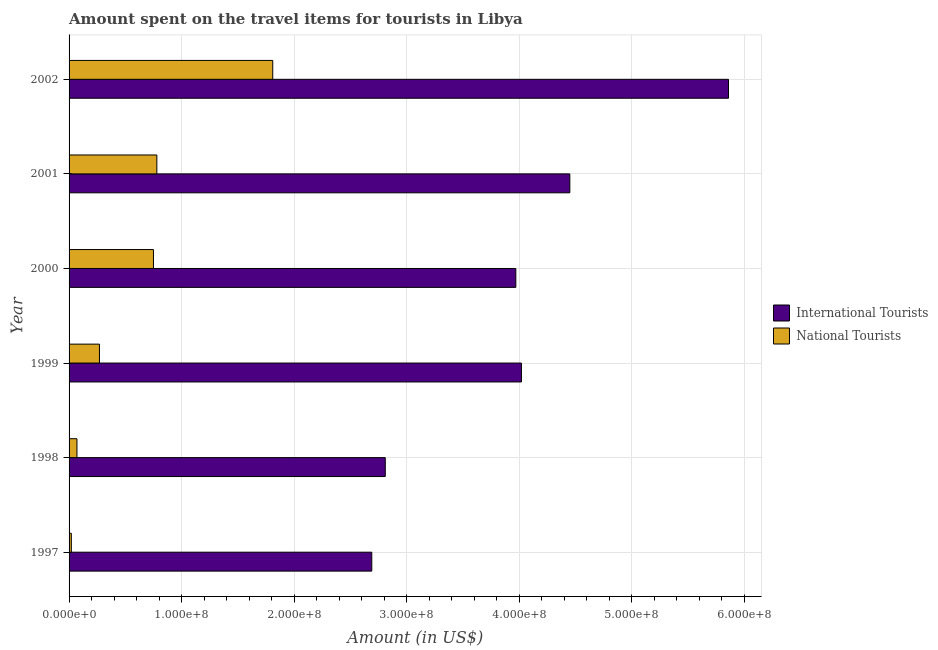How many different coloured bars are there?
Your answer should be compact. 2. How many groups of bars are there?
Make the answer very short. 6. Are the number of bars per tick equal to the number of legend labels?
Keep it short and to the point. Yes. How many bars are there on the 6th tick from the bottom?
Offer a very short reply. 2. What is the amount spent on travel items of international tourists in 1999?
Give a very brief answer. 4.02e+08. Across all years, what is the maximum amount spent on travel items of national tourists?
Your response must be concise. 1.81e+08. Across all years, what is the minimum amount spent on travel items of international tourists?
Provide a short and direct response. 2.69e+08. What is the total amount spent on travel items of national tourists in the graph?
Provide a succinct answer. 3.70e+08. What is the difference between the amount spent on travel items of international tourists in 1998 and that in 2000?
Offer a terse response. -1.16e+08. What is the difference between the amount spent on travel items of international tourists in 1998 and the amount spent on travel items of national tourists in 1997?
Offer a very short reply. 2.79e+08. What is the average amount spent on travel items of national tourists per year?
Provide a short and direct response. 6.17e+07. In the year 2001, what is the difference between the amount spent on travel items of international tourists and amount spent on travel items of national tourists?
Your answer should be very brief. 3.67e+08. What is the ratio of the amount spent on travel items of international tourists in 1998 to that in 2001?
Provide a short and direct response. 0.63. Is the difference between the amount spent on travel items of national tourists in 1999 and 2002 greater than the difference between the amount spent on travel items of international tourists in 1999 and 2002?
Your answer should be compact. Yes. What is the difference between the highest and the second highest amount spent on travel items of international tourists?
Make the answer very short. 1.41e+08. What is the difference between the highest and the lowest amount spent on travel items of national tourists?
Ensure brevity in your answer.  1.79e+08. Is the sum of the amount spent on travel items of international tourists in 1998 and 2001 greater than the maximum amount spent on travel items of national tourists across all years?
Your answer should be very brief. Yes. What does the 2nd bar from the top in 1998 represents?
Offer a very short reply. International Tourists. What does the 1st bar from the bottom in 1998 represents?
Provide a succinct answer. International Tourists. How many bars are there?
Your answer should be compact. 12. Are all the bars in the graph horizontal?
Offer a terse response. Yes. How many years are there in the graph?
Give a very brief answer. 6. What is the difference between two consecutive major ticks on the X-axis?
Offer a very short reply. 1.00e+08. Where does the legend appear in the graph?
Provide a short and direct response. Center right. How are the legend labels stacked?
Offer a terse response. Vertical. What is the title of the graph?
Make the answer very short. Amount spent on the travel items for tourists in Libya. What is the label or title of the Y-axis?
Keep it short and to the point. Year. What is the Amount (in US$) in International Tourists in 1997?
Offer a terse response. 2.69e+08. What is the Amount (in US$) of International Tourists in 1998?
Your response must be concise. 2.81e+08. What is the Amount (in US$) of National Tourists in 1998?
Keep it short and to the point. 7.00e+06. What is the Amount (in US$) of International Tourists in 1999?
Ensure brevity in your answer.  4.02e+08. What is the Amount (in US$) in National Tourists in 1999?
Provide a succinct answer. 2.70e+07. What is the Amount (in US$) in International Tourists in 2000?
Offer a terse response. 3.97e+08. What is the Amount (in US$) in National Tourists in 2000?
Your response must be concise. 7.50e+07. What is the Amount (in US$) of International Tourists in 2001?
Provide a short and direct response. 4.45e+08. What is the Amount (in US$) in National Tourists in 2001?
Your answer should be compact. 7.80e+07. What is the Amount (in US$) of International Tourists in 2002?
Offer a terse response. 5.86e+08. What is the Amount (in US$) of National Tourists in 2002?
Ensure brevity in your answer.  1.81e+08. Across all years, what is the maximum Amount (in US$) of International Tourists?
Your answer should be very brief. 5.86e+08. Across all years, what is the maximum Amount (in US$) in National Tourists?
Your answer should be very brief. 1.81e+08. Across all years, what is the minimum Amount (in US$) in International Tourists?
Keep it short and to the point. 2.69e+08. Across all years, what is the minimum Amount (in US$) of National Tourists?
Provide a succinct answer. 2.00e+06. What is the total Amount (in US$) of International Tourists in the graph?
Keep it short and to the point. 2.38e+09. What is the total Amount (in US$) in National Tourists in the graph?
Offer a very short reply. 3.70e+08. What is the difference between the Amount (in US$) in International Tourists in 1997 and that in 1998?
Your response must be concise. -1.20e+07. What is the difference between the Amount (in US$) of National Tourists in 1997 and that in 1998?
Keep it short and to the point. -5.00e+06. What is the difference between the Amount (in US$) of International Tourists in 1997 and that in 1999?
Offer a very short reply. -1.33e+08. What is the difference between the Amount (in US$) of National Tourists in 1997 and that in 1999?
Your answer should be very brief. -2.50e+07. What is the difference between the Amount (in US$) in International Tourists in 1997 and that in 2000?
Give a very brief answer. -1.28e+08. What is the difference between the Amount (in US$) in National Tourists in 1997 and that in 2000?
Your response must be concise. -7.30e+07. What is the difference between the Amount (in US$) of International Tourists in 1997 and that in 2001?
Your answer should be compact. -1.76e+08. What is the difference between the Amount (in US$) in National Tourists in 1997 and that in 2001?
Your response must be concise. -7.60e+07. What is the difference between the Amount (in US$) of International Tourists in 1997 and that in 2002?
Ensure brevity in your answer.  -3.17e+08. What is the difference between the Amount (in US$) in National Tourists in 1997 and that in 2002?
Your answer should be compact. -1.79e+08. What is the difference between the Amount (in US$) of International Tourists in 1998 and that in 1999?
Provide a short and direct response. -1.21e+08. What is the difference between the Amount (in US$) of National Tourists in 1998 and that in 1999?
Make the answer very short. -2.00e+07. What is the difference between the Amount (in US$) in International Tourists in 1998 and that in 2000?
Provide a succinct answer. -1.16e+08. What is the difference between the Amount (in US$) of National Tourists in 1998 and that in 2000?
Your answer should be very brief. -6.80e+07. What is the difference between the Amount (in US$) in International Tourists in 1998 and that in 2001?
Offer a terse response. -1.64e+08. What is the difference between the Amount (in US$) in National Tourists in 1998 and that in 2001?
Provide a short and direct response. -7.10e+07. What is the difference between the Amount (in US$) of International Tourists in 1998 and that in 2002?
Your response must be concise. -3.05e+08. What is the difference between the Amount (in US$) of National Tourists in 1998 and that in 2002?
Offer a very short reply. -1.74e+08. What is the difference between the Amount (in US$) of National Tourists in 1999 and that in 2000?
Your response must be concise. -4.80e+07. What is the difference between the Amount (in US$) of International Tourists in 1999 and that in 2001?
Make the answer very short. -4.30e+07. What is the difference between the Amount (in US$) in National Tourists in 1999 and that in 2001?
Provide a succinct answer. -5.10e+07. What is the difference between the Amount (in US$) of International Tourists in 1999 and that in 2002?
Make the answer very short. -1.84e+08. What is the difference between the Amount (in US$) of National Tourists in 1999 and that in 2002?
Offer a terse response. -1.54e+08. What is the difference between the Amount (in US$) in International Tourists in 2000 and that in 2001?
Provide a short and direct response. -4.80e+07. What is the difference between the Amount (in US$) in National Tourists in 2000 and that in 2001?
Your answer should be compact. -3.00e+06. What is the difference between the Amount (in US$) of International Tourists in 2000 and that in 2002?
Keep it short and to the point. -1.89e+08. What is the difference between the Amount (in US$) of National Tourists in 2000 and that in 2002?
Offer a terse response. -1.06e+08. What is the difference between the Amount (in US$) of International Tourists in 2001 and that in 2002?
Offer a terse response. -1.41e+08. What is the difference between the Amount (in US$) of National Tourists in 2001 and that in 2002?
Your response must be concise. -1.03e+08. What is the difference between the Amount (in US$) in International Tourists in 1997 and the Amount (in US$) in National Tourists in 1998?
Your answer should be compact. 2.62e+08. What is the difference between the Amount (in US$) in International Tourists in 1997 and the Amount (in US$) in National Tourists in 1999?
Keep it short and to the point. 2.42e+08. What is the difference between the Amount (in US$) in International Tourists in 1997 and the Amount (in US$) in National Tourists in 2000?
Your answer should be very brief. 1.94e+08. What is the difference between the Amount (in US$) in International Tourists in 1997 and the Amount (in US$) in National Tourists in 2001?
Make the answer very short. 1.91e+08. What is the difference between the Amount (in US$) in International Tourists in 1997 and the Amount (in US$) in National Tourists in 2002?
Keep it short and to the point. 8.80e+07. What is the difference between the Amount (in US$) in International Tourists in 1998 and the Amount (in US$) in National Tourists in 1999?
Keep it short and to the point. 2.54e+08. What is the difference between the Amount (in US$) of International Tourists in 1998 and the Amount (in US$) of National Tourists in 2000?
Give a very brief answer. 2.06e+08. What is the difference between the Amount (in US$) in International Tourists in 1998 and the Amount (in US$) in National Tourists in 2001?
Your answer should be compact. 2.03e+08. What is the difference between the Amount (in US$) of International Tourists in 1999 and the Amount (in US$) of National Tourists in 2000?
Give a very brief answer. 3.27e+08. What is the difference between the Amount (in US$) in International Tourists in 1999 and the Amount (in US$) in National Tourists in 2001?
Your answer should be very brief. 3.24e+08. What is the difference between the Amount (in US$) of International Tourists in 1999 and the Amount (in US$) of National Tourists in 2002?
Offer a terse response. 2.21e+08. What is the difference between the Amount (in US$) in International Tourists in 2000 and the Amount (in US$) in National Tourists in 2001?
Ensure brevity in your answer.  3.19e+08. What is the difference between the Amount (in US$) of International Tourists in 2000 and the Amount (in US$) of National Tourists in 2002?
Provide a short and direct response. 2.16e+08. What is the difference between the Amount (in US$) in International Tourists in 2001 and the Amount (in US$) in National Tourists in 2002?
Your response must be concise. 2.64e+08. What is the average Amount (in US$) in International Tourists per year?
Your response must be concise. 3.97e+08. What is the average Amount (in US$) of National Tourists per year?
Give a very brief answer. 6.17e+07. In the year 1997, what is the difference between the Amount (in US$) of International Tourists and Amount (in US$) of National Tourists?
Provide a short and direct response. 2.67e+08. In the year 1998, what is the difference between the Amount (in US$) of International Tourists and Amount (in US$) of National Tourists?
Ensure brevity in your answer.  2.74e+08. In the year 1999, what is the difference between the Amount (in US$) in International Tourists and Amount (in US$) in National Tourists?
Make the answer very short. 3.75e+08. In the year 2000, what is the difference between the Amount (in US$) in International Tourists and Amount (in US$) in National Tourists?
Make the answer very short. 3.22e+08. In the year 2001, what is the difference between the Amount (in US$) of International Tourists and Amount (in US$) of National Tourists?
Provide a short and direct response. 3.67e+08. In the year 2002, what is the difference between the Amount (in US$) of International Tourists and Amount (in US$) of National Tourists?
Your response must be concise. 4.05e+08. What is the ratio of the Amount (in US$) of International Tourists in 1997 to that in 1998?
Your answer should be very brief. 0.96. What is the ratio of the Amount (in US$) of National Tourists in 1997 to that in 1998?
Keep it short and to the point. 0.29. What is the ratio of the Amount (in US$) of International Tourists in 1997 to that in 1999?
Your answer should be compact. 0.67. What is the ratio of the Amount (in US$) of National Tourists in 1997 to that in 1999?
Ensure brevity in your answer.  0.07. What is the ratio of the Amount (in US$) in International Tourists in 1997 to that in 2000?
Offer a very short reply. 0.68. What is the ratio of the Amount (in US$) in National Tourists in 1997 to that in 2000?
Provide a succinct answer. 0.03. What is the ratio of the Amount (in US$) in International Tourists in 1997 to that in 2001?
Provide a succinct answer. 0.6. What is the ratio of the Amount (in US$) of National Tourists in 1997 to that in 2001?
Your answer should be compact. 0.03. What is the ratio of the Amount (in US$) in International Tourists in 1997 to that in 2002?
Keep it short and to the point. 0.46. What is the ratio of the Amount (in US$) in National Tourists in 1997 to that in 2002?
Provide a succinct answer. 0.01. What is the ratio of the Amount (in US$) of International Tourists in 1998 to that in 1999?
Offer a very short reply. 0.7. What is the ratio of the Amount (in US$) of National Tourists in 1998 to that in 1999?
Ensure brevity in your answer.  0.26. What is the ratio of the Amount (in US$) of International Tourists in 1998 to that in 2000?
Provide a short and direct response. 0.71. What is the ratio of the Amount (in US$) of National Tourists in 1998 to that in 2000?
Your answer should be very brief. 0.09. What is the ratio of the Amount (in US$) in International Tourists in 1998 to that in 2001?
Provide a short and direct response. 0.63. What is the ratio of the Amount (in US$) in National Tourists in 1998 to that in 2001?
Your response must be concise. 0.09. What is the ratio of the Amount (in US$) of International Tourists in 1998 to that in 2002?
Ensure brevity in your answer.  0.48. What is the ratio of the Amount (in US$) of National Tourists in 1998 to that in 2002?
Give a very brief answer. 0.04. What is the ratio of the Amount (in US$) of International Tourists in 1999 to that in 2000?
Give a very brief answer. 1.01. What is the ratio of the Amount (in US$) in National Tourists in 1999 to that in 2000?
Provide a short and direct response. 0.36. What is the ratio of the Amount (in US$) of International Tourists in 1999 to that in 2001?
Ensure brevity in your answer.  0.9. What is the ratio of the Amount (in US$) in National Tourists in 1999 to that in 2001?
Your answer should be compact. 0.35. What is the ratio of the Amount (in US$) in International Tourists in 1999 to that in 2002?
Your answer should be compact. 0.69. What is the ratio of the Amount (in US$) in National Tourists in 1999 to that in 2002?
Ensure brevity in your answer.  0.15. What is the ratio of the Amount (in US$) of International Tourists in 2000 to that in 2001?
Provide a short and direct response. 0.89. What is the ratio of the Amount (in US$) of National Tourists in 2000 to that in 2001?
Give a very brief answer. 0.96. What is the ratio of the Amount (in US$) of International Tourists in 2000 to that in 2002?
Offer a very short reply. 0.68. What is the ratio of the Amount (in US$) in National Tourists in 2000 to that in 2002?
Make the answer very short. 0.41. What is the ratio of the Amount (in US$) in International Tourists in 2001 to that in 2002?
Keep it short and to the point. 0.76. What is the ratio of the Amount (in US$) in National Tourists in 2001 to that in 2002?
Provide a short and direct response. 0.43. What is the difference between the highest and the second highest Amount (in US$) of International Tourists?
Make the answer very short. 1.41e+08. What is the difference between the highest and the second highest Amount (in US$) of National Tourists?
Ensure brevity in your answer.  1.03e+08. What is the difference between the highest and the lowest Amount (in US$) in International Tourists?
Offer a terse response. 3.17e+08. What is the difference between the highest and the lowest Amount (in US$) in National Tourists?
Provide a short and direct response. 1.79e+08. 